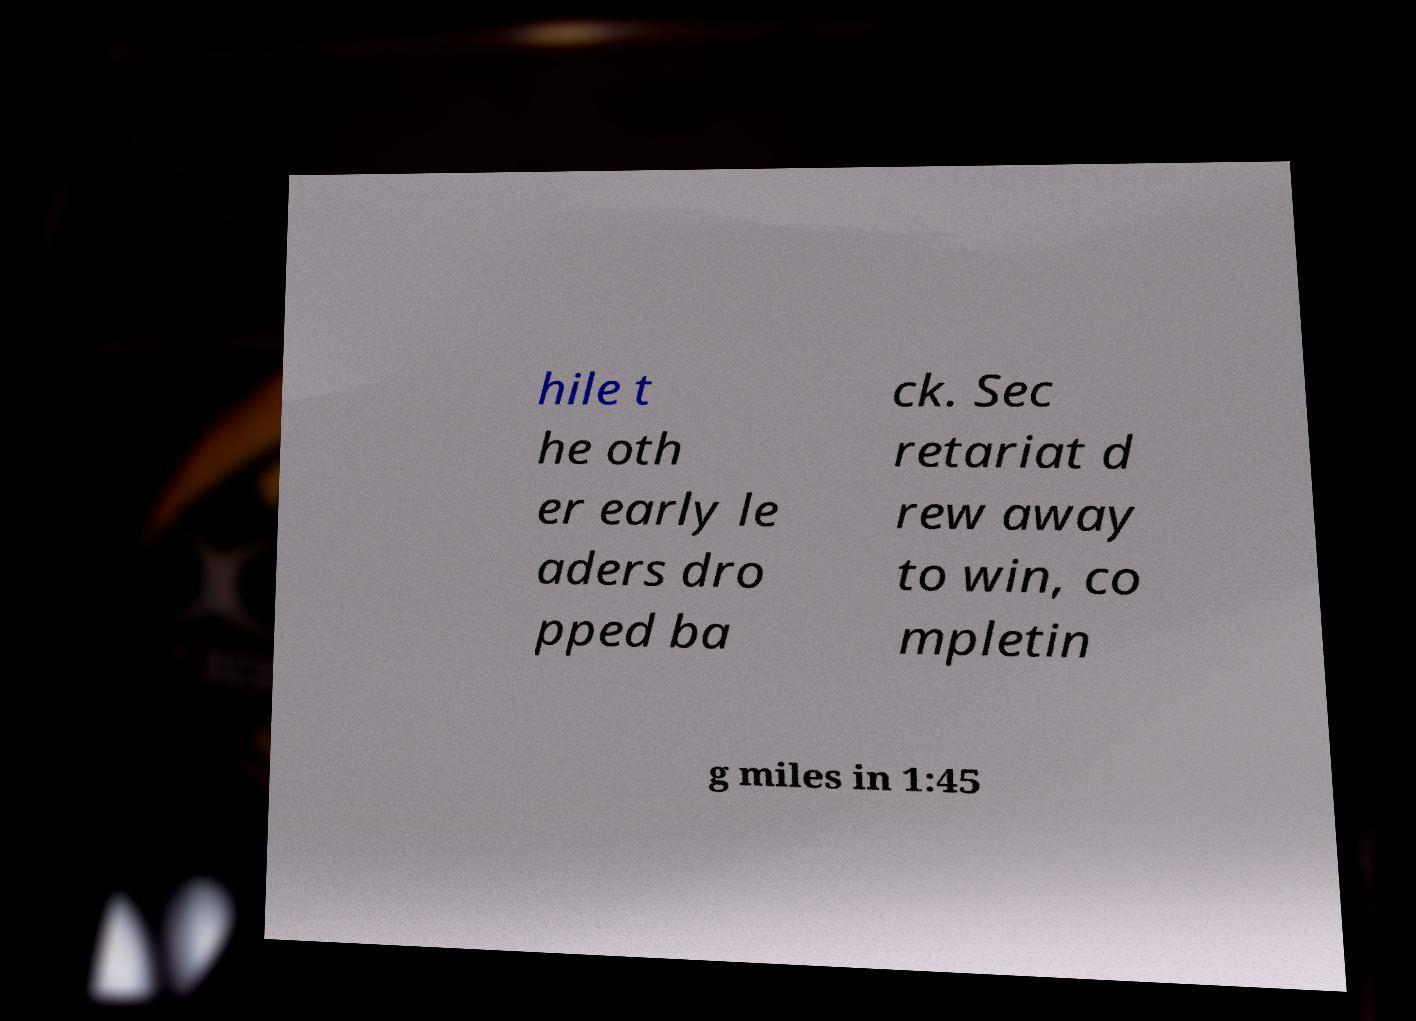Please identify and transcribe the text found in this image. hile t he oth er early le aders dro pped ba ck. Sec retariat d rew away to win, co mpletin g miles in 1:45 